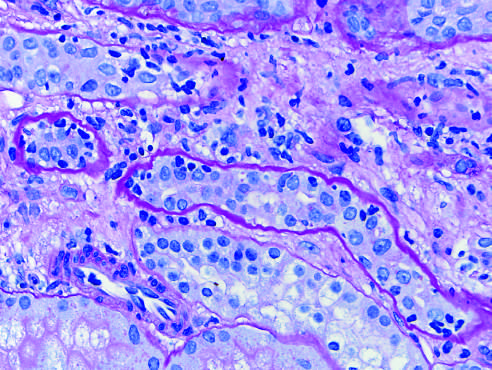s acute cellular rejection of a kidney graft manifested by inflammatory cells in the inter-stitium and between epithelial cells of the tubules tubulitis?
Answer the question using a single word or phrase. Yes 